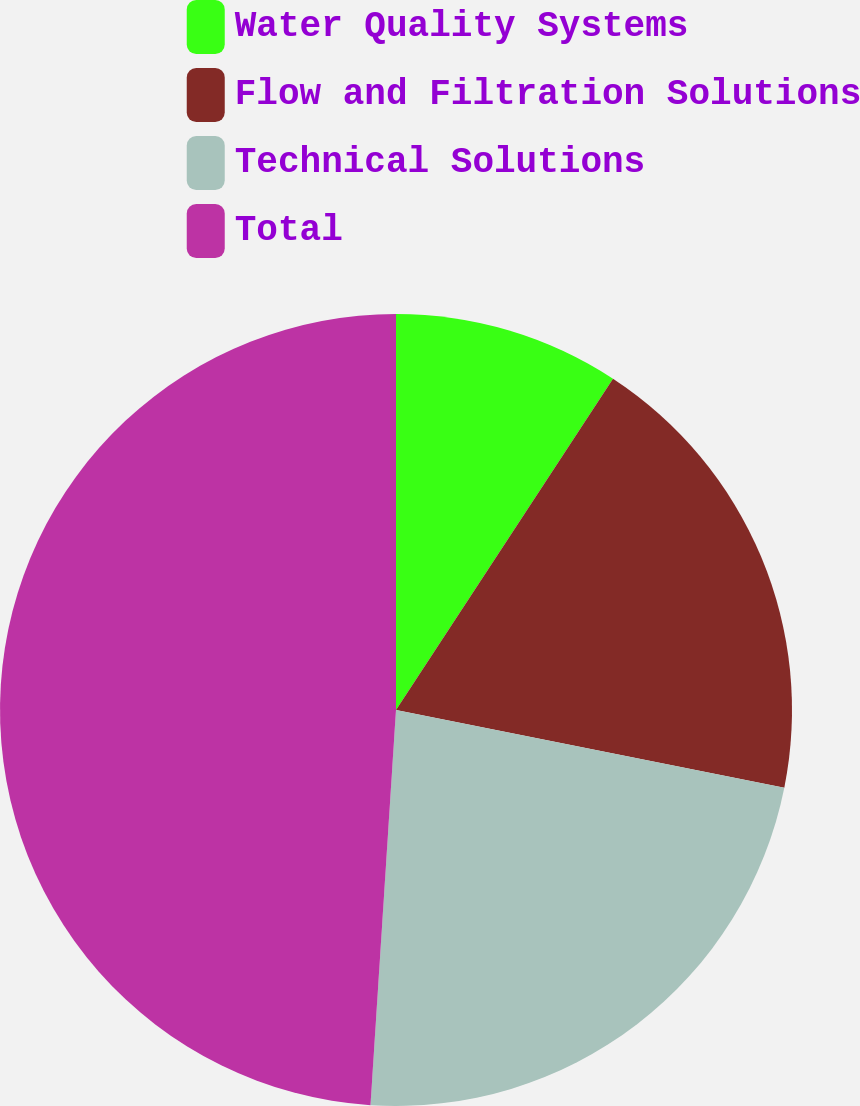Convert chart. <chart><loc_0><loc_0><loc_500><loc_500><pie_chart><fcel>Water Quality Systems<fcel>Flow and Filtration Solutions<fcel>Technical Solutions<fcel>Total<nl><fcel>9.23%<fcel>18.91%<fcel>22.88%<fcel>48.97%<nl></chart> 